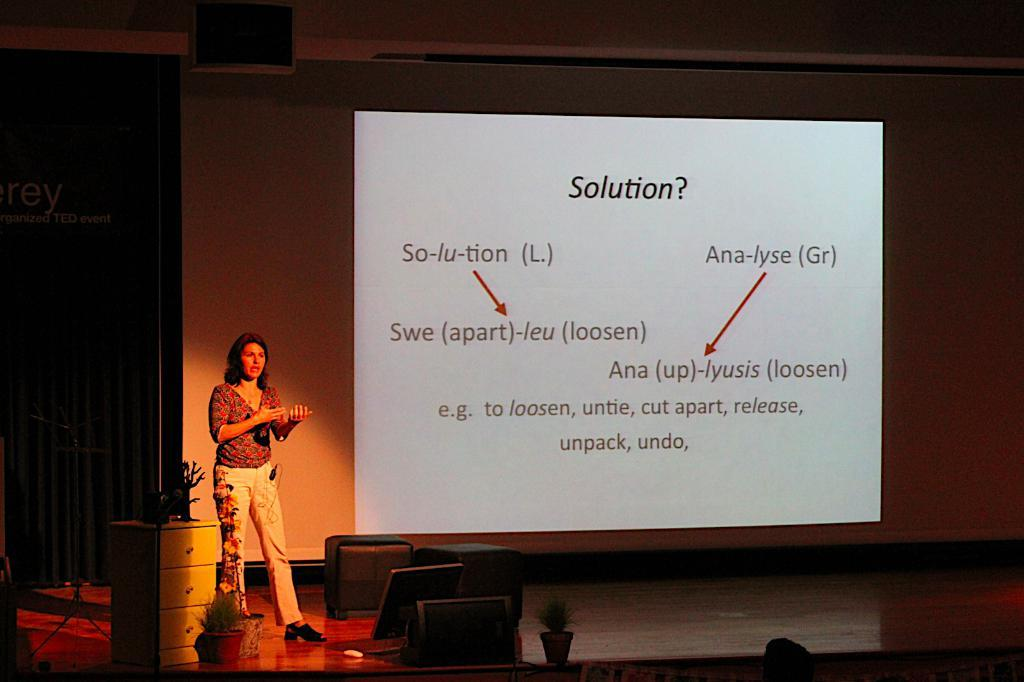What is the woman doing on the stage? The woman is standing on the stage and explaining something. What can be found on the stage besides the woman? There are drawers and other things on the stage. What is located behind the woman on the stage? There is a screen behind the woman. What type of straw is being used by the woman to act out a scene in the image? There is no straw present in the image, and the woman is not acting out a scene. 